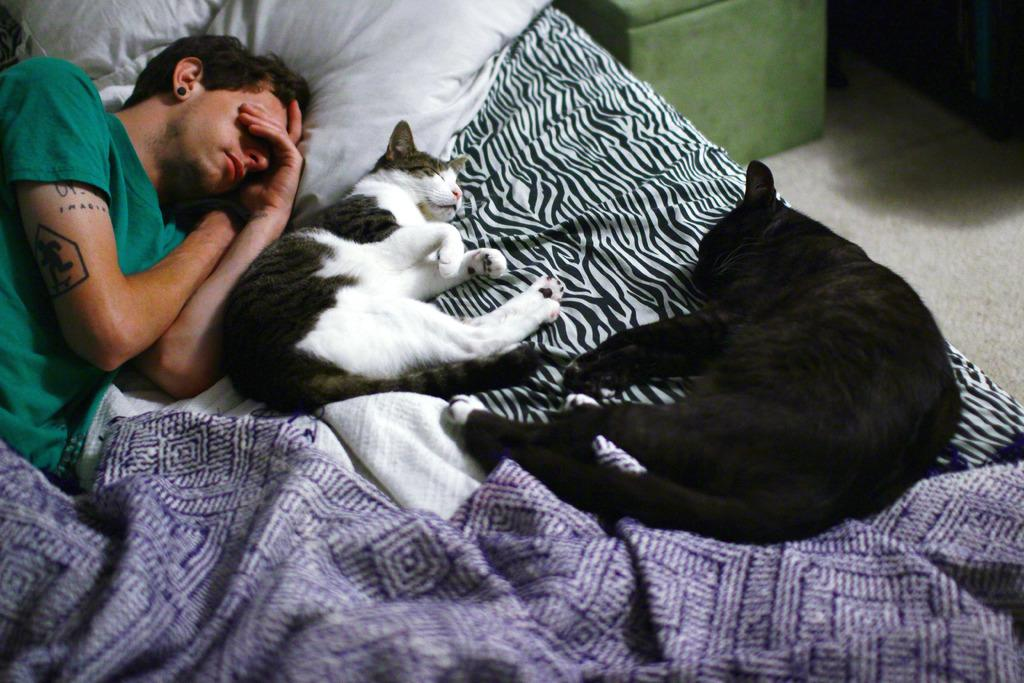What is the man in the image doing? The man is laying on the bed. What is covering the bed? There is a blanket on the bed. What type of animals are in the image? There are cats in the image. What is supporting the man's head on the bed? There is a pillow on the bed. What part of the room can be seen in the image? The floor is visible in the image. What type of cloud can be seen in the image? There is no cloud present in the image; it features a man laying on a bed with cats and other items. What type of rail is visible in the image? There is no rail present in the image. 